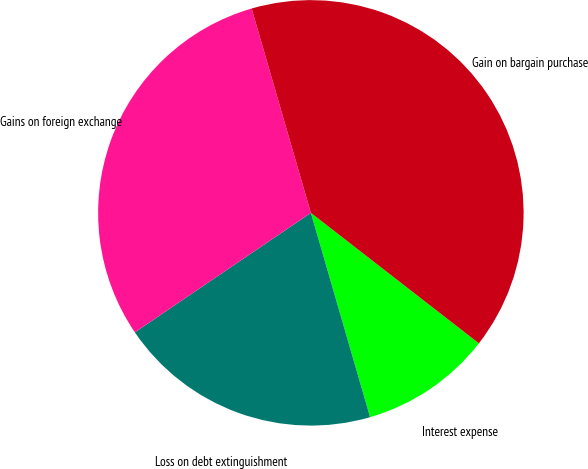Convert chart to OTSL. <chart><loc_0><loc_0><loc_500><loc_500><pie_chart><fcel>Interest expense<fcel>Loss on debt extinguishment<fcel>Gains on foreign exchange<fcel>Gain on bargain purchase<nl><fcel>10.0%<fcel>20.0%<fcel>30.0%<fcel>40.0%<nl></chart> 